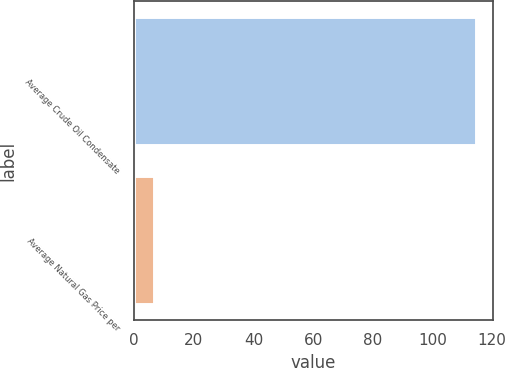Convert chart. <chart><loc_0><loc_0><loc_500><loc_500><bar_chart><fcel>Average Crude Oil Condensate<fcel>Average Natural Gas Price per<nl><fcel>114.54<fcel>6.77<nl></chart> 